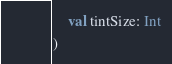Convert code to text. <code><loc_0><loc_0><loc_500><loc_500><_Kotlin_>    val tintSize: Int
)</code> 